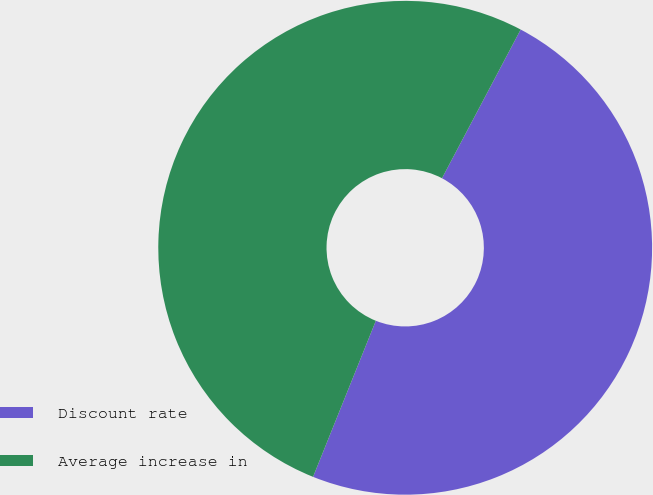Convert chart. <chart><loc_0><loc_0><loc_500><loc_500><pie_chart><fcel>Discount rate<fcel>Average increase in<nl><fcel>48.34%<fcel>51.66%<nl></chart> 